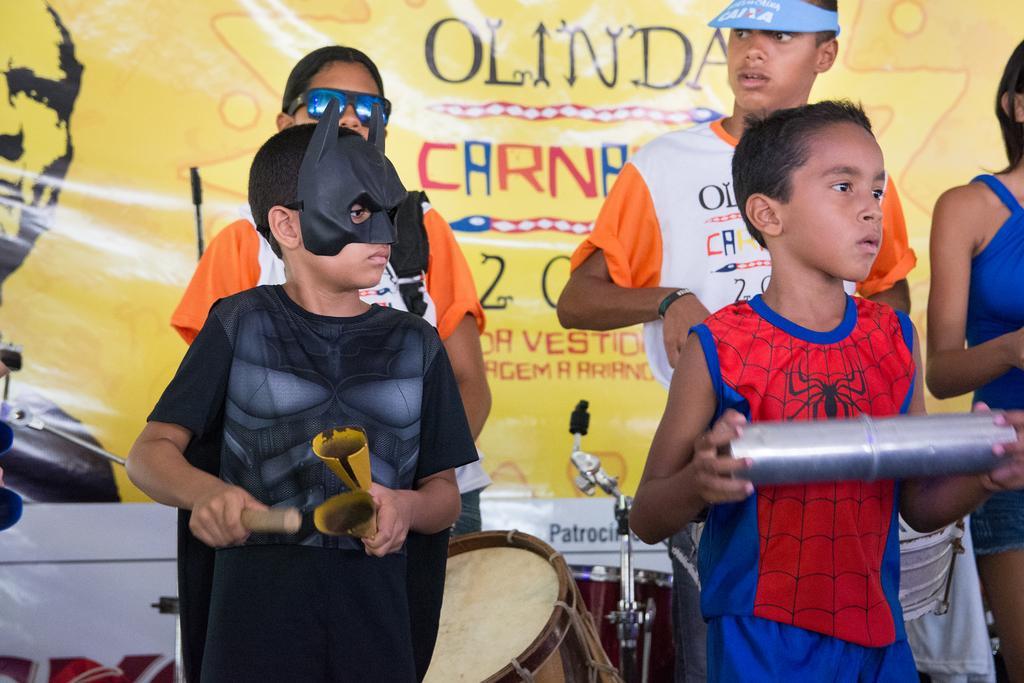How would you summarize this image in a sentence or two? In this picture there are children in the center of the image and there is a drum at the bottom side of the image, there is a flex in the background area of the image. 